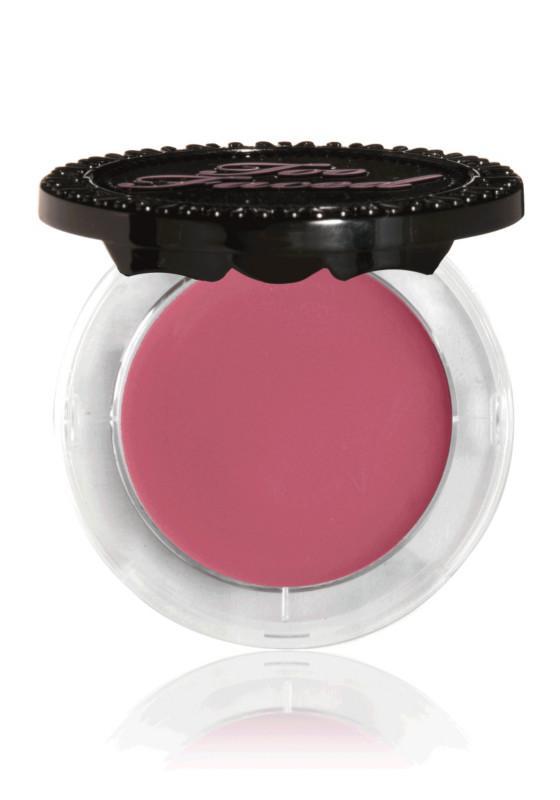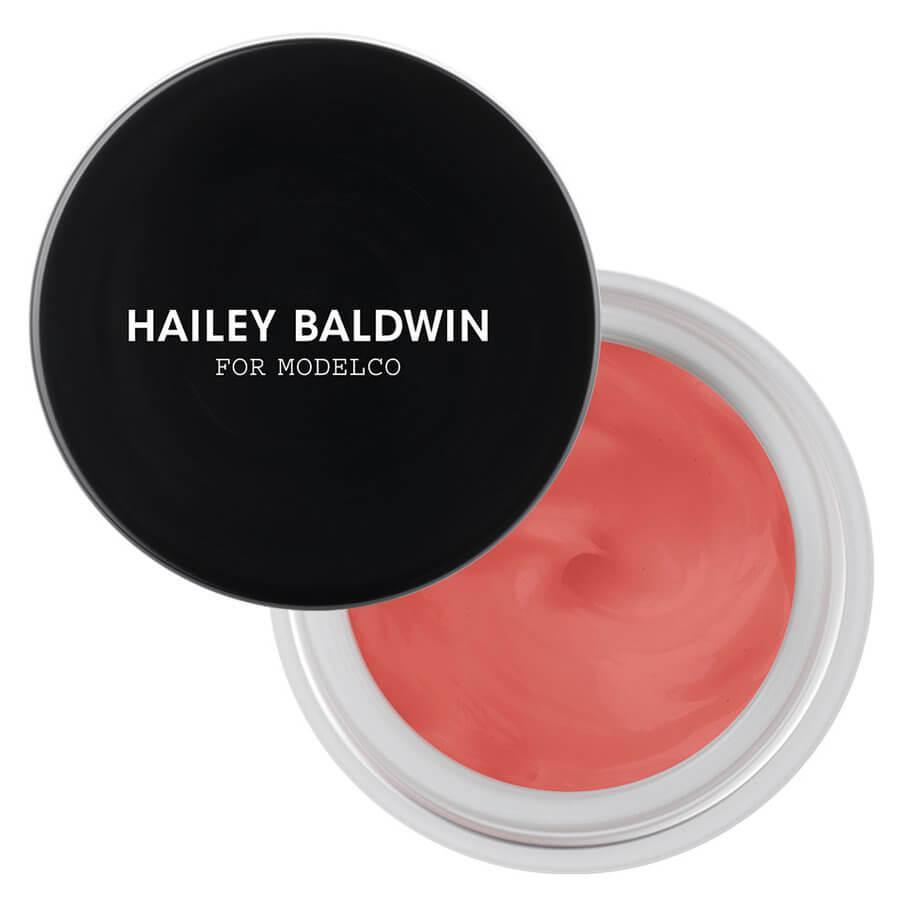The first image is the image on the left, the second image is the image on the right. Considering the images on both sides, is "The image on the right contains an opened jar with lid." valid? Answer yes or no. Yes. 